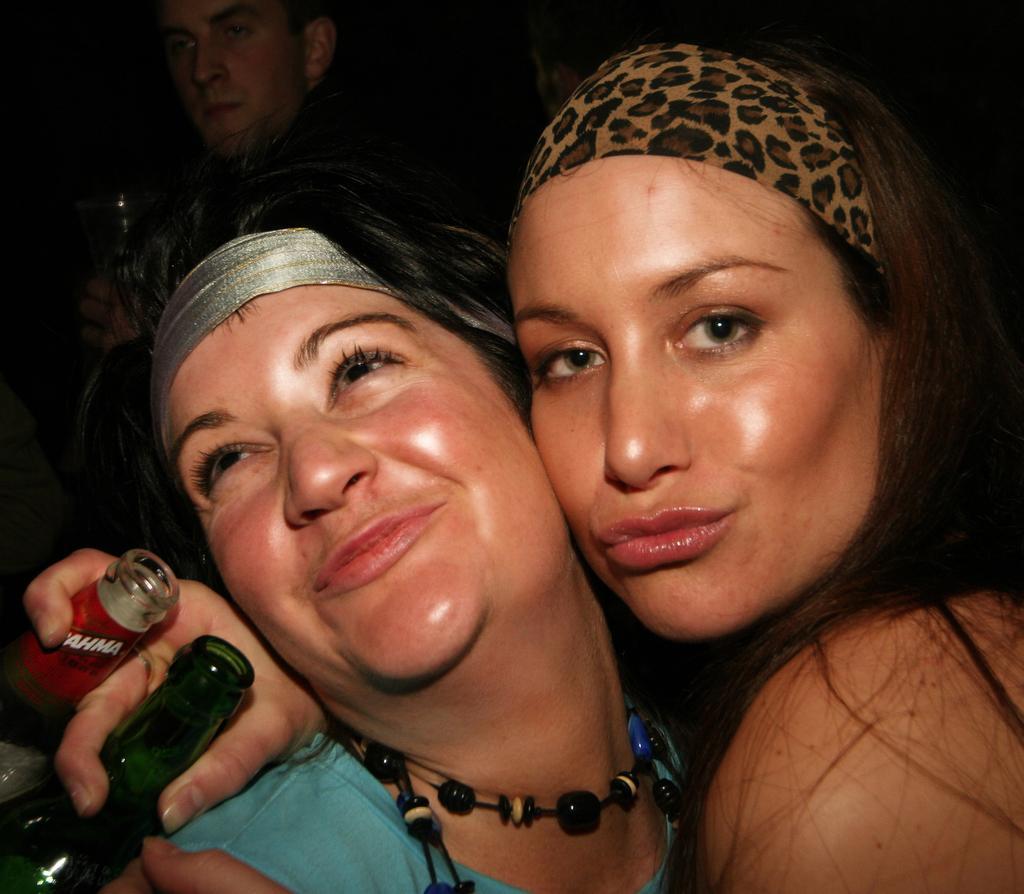How would you summarize this image in a sentence or two? There are two women. They are smiling. She is holding bottles with her hand. On the background there is a man. 